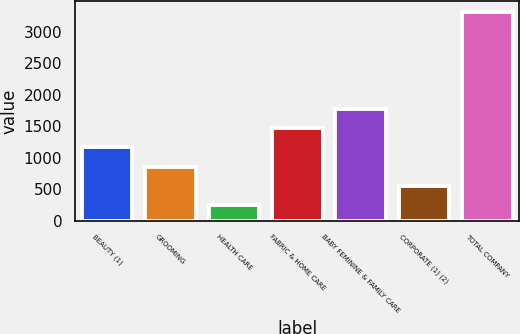<chart> <loc_0><loc_0><loc_500><loc_500><bar_chart><fcel>BEAUTY (1)<fcel>GROOMING<fcel>HEALTH CARE<fcel>FABRIC & HOME CARE<fcel>BABY FEMININE & FAMILY CARE<fcel>CORPORATE (1) (2)<fcel>TOTAL COMPANY<nl><fcel>1162.2<fcel>854.8<fcel>240<fcel>1469.6<fcel>1777<fcel>547.4<fcel>3314<nl></chart> 